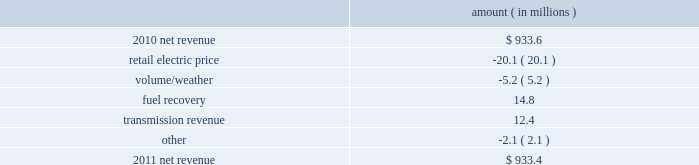Entergy gulf states louisiana , l.l.c .
Management 2019s financial discussion and analysis plan to spin off the utility 2019s transmission business see the 201cplan to spin off the utility 2019s transmission business 201d section of entergy corporation and subsidiaries management 2019s financial discussion and analysis for a discussion of this matter , including the planned retirement of debt and preferred securities .
Results of operations net income 2011 compared to 2010 net income increased $ 12.3 million primarily due to lower interest expense and lower other operation and maintenance expenses , offset by higher depreciation and amortization expenses and a higher effective income tax 2010 compared to 2009 net income increased $ 37.7 million primarily due to higher net revenue , a lower effective income tax rate , and lower interest expense , offset by higher other operation and maintenance expenses , lower other income , and higher taxes other than income taxes .
Net revenue 2011 compared to 2010 net revenue consists of operating revenues net of : 1 ) fuel , fuel-related expenses , and gas purchased for resale , 2 ) purchased power expenses , and 3 ) other regulatory credits .
Following is an analysis of the change in net revenue comparing 2011 to 2010 .
Amount ( in millions ) .
The retail electric price variance is primarily due to an increase in credits passed on to customers as a result of the act 55 storm cost financing .
See 201cmanagement 2019s financial discussion and analysis 2013 hurricane gustav and hurricane ike 201d and note 2 to the financial statements for a discussion of the act 55 storm cost financing .
The volume/weather variance is primarily due to less favorable weather on the residential sector as well as the unbilled sales period .
The decrease was partially offset by an increase of 62 gwh , or 0.3% ( 0.3 % ) , in billed electricity usage , primarily due to increased consumption by an industrial customer as a result of the customer 2019s cogeneration outage and the addition of a new production unit by the industrial customer .
The fuel recovery variance resulted primarily from an adjustment to deferred fuel costs in 2010 .
See note 2 to the financial statements for a discussion of fuel recovery. .
What as the percent of the net revenue from transmission in 2011? 
Computations: (12.4 / 933.4)
Answer: 0.01328. Entergy gulf states louisiana , l.l.c .
Management 2019s financial discussion and analysis plan to spin off the utility 2019s transmission business see the 201cplan to spin off the utility 2019s transmission business 201d section of entergy corporation and subsidiaries management 2019s financial discussion and analysis for a discussion of this matter , including the planned retirement of debt and preferred securities .
Results of operations net income 2011 compared to 2010 net income increased $ 12.3 million primarily due to lower interest expense and lower other operation and maintenance expenses , offset by higher depreciation and amortization expenses and a higher effective income tax 2010 compared to 2009 net income increased $ 37.7 million primarily due to higher net revenue , a lower effective income tax rate , and lower interest expense , offset by higher other operation and maintenance expenses , lower other income , and higher taxes other than income taxes .
Net revenue 2011 compared to 2010 net revenue consists of operating revenues net of : 1 ) fuel , fuel-related expenses , and gas purchased for resale , 2 ) purchased power expenses , and 3 ) other regulatory credits .
Following is an analysis of the change in net revenue comparing 2011 to 2010 .
Amount ( in millions ) .
The retail electric price variance is primarily due to an increase in credits passed on to customers as a result of the act 55 storm cost financing .
See 201cmanagement 2019s financial discussion and analysis 2013 hurricane gustav and hurricane ike 201d and note 2 to the financial statements for a discussion of the act 55 storm cost financing .
The volume/weather variance is primarily due to less favorable weather on the residential sector as well as the unbilled sales period .
The decrease was partially offset by an increase of 62 gwh , or 0.3% ( 0.3 % ) , in billed electricity usage , primarily due to increased consumption by an industrial customer as a result of the customer 2019s cogeneration outage and the addition of a new production unit by the industrial customer .
The fuel recovery variance resulted primarily from an adjustment to deferred fuel costs in 2010 .
See note 2 to the financial statements for a discussion of fuel recovery. .
By what percentage point did the net income margin improve in 2010? 
Computations: (37.7 / 933.6)
Answer: 0.04038. 